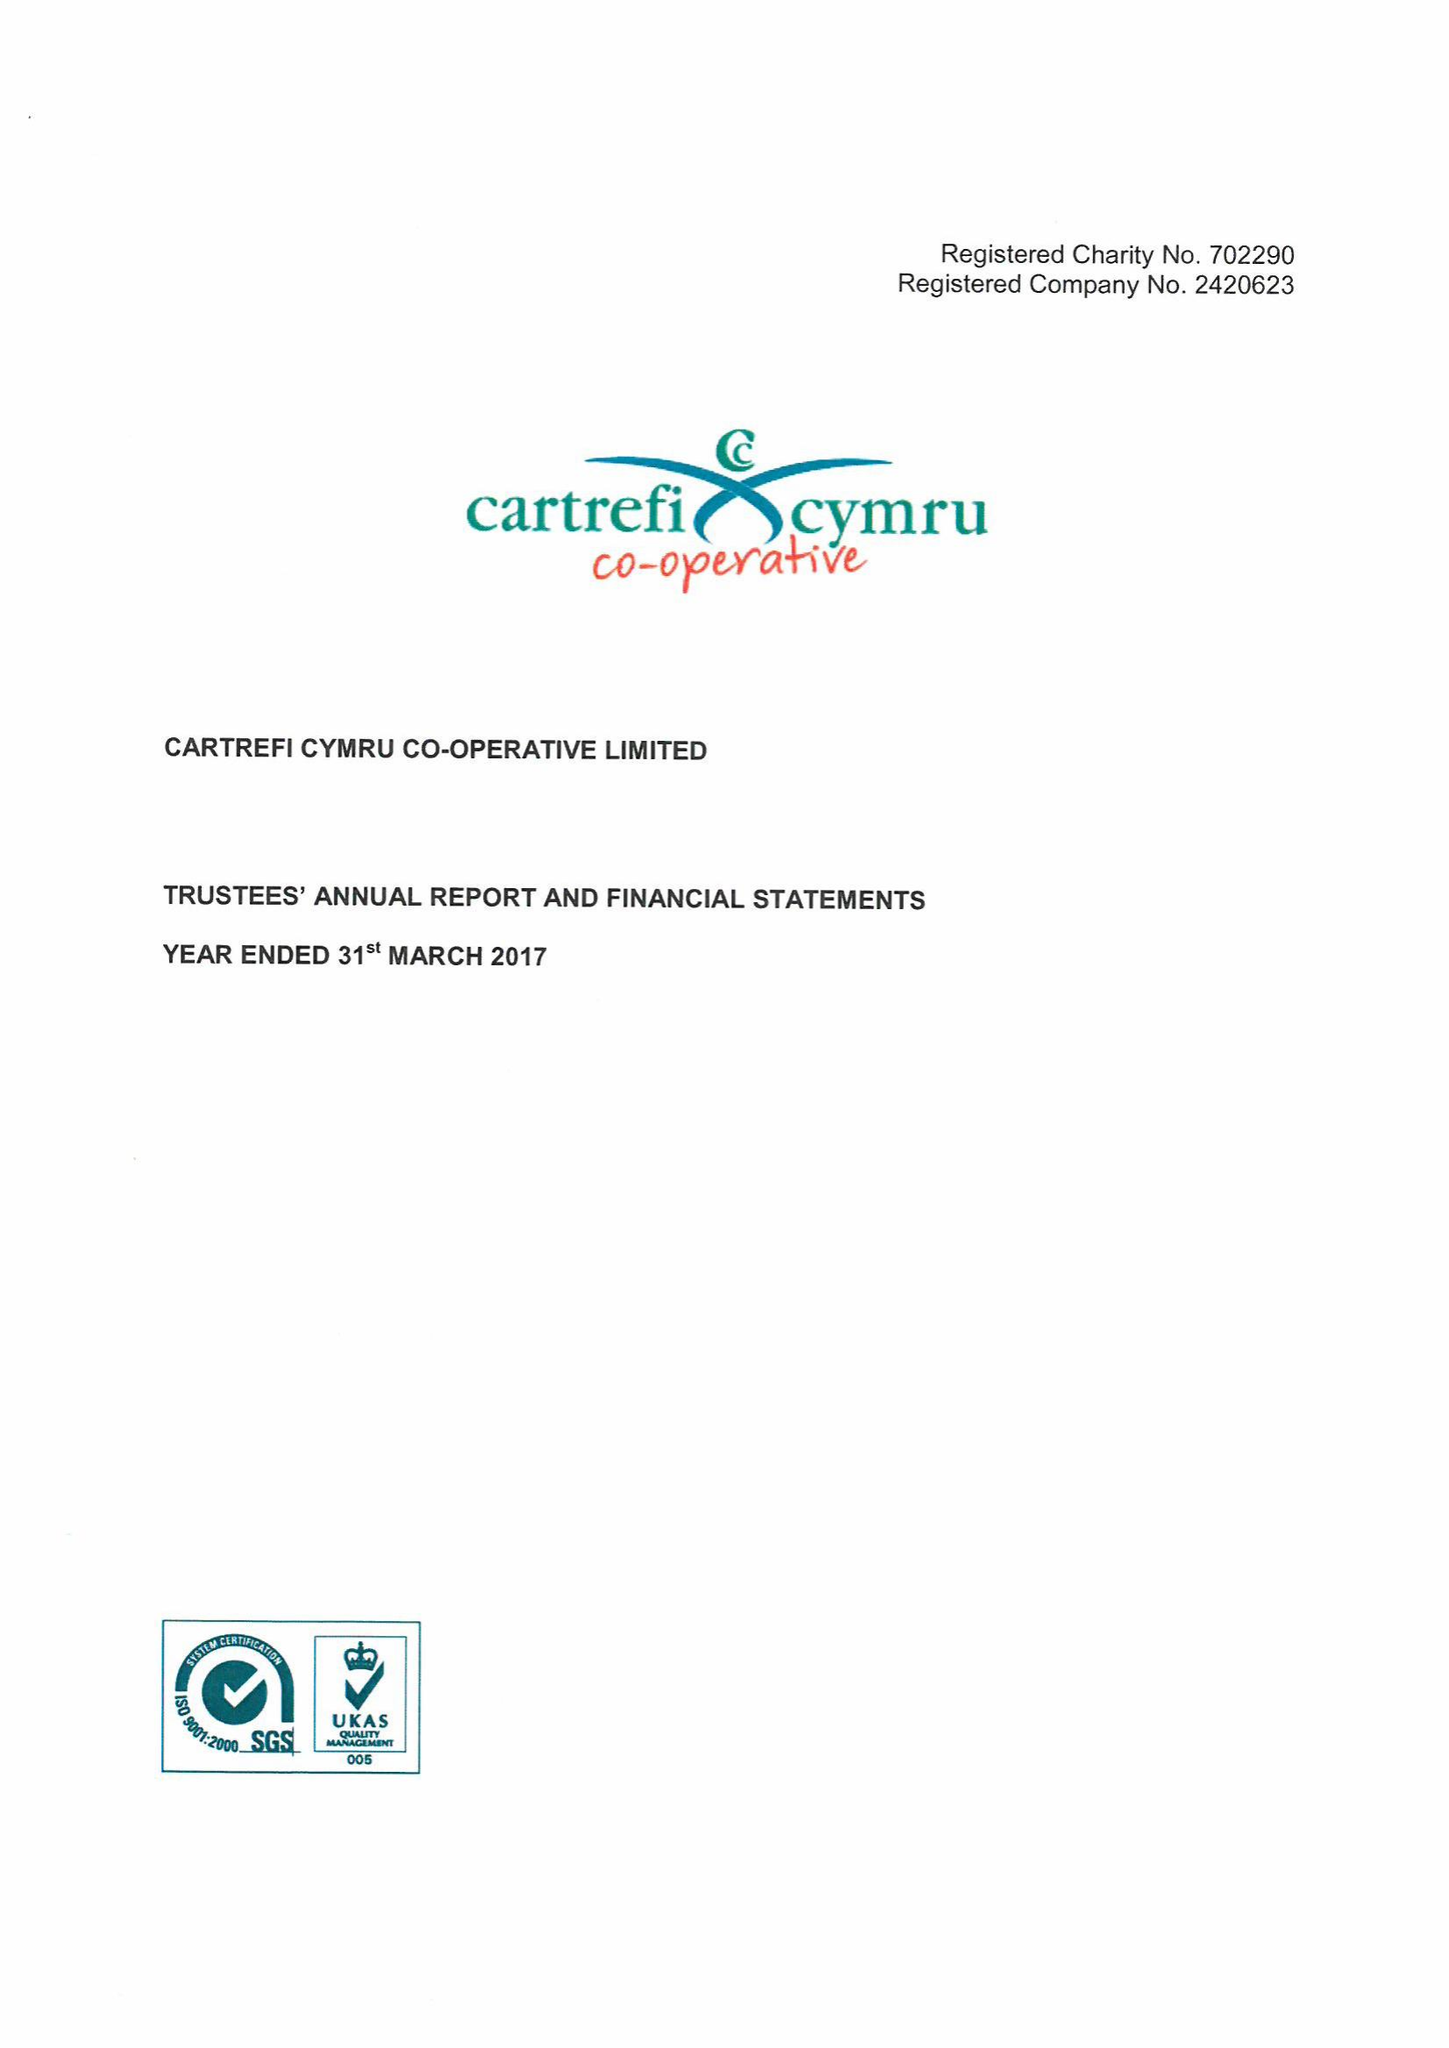What is the value for the address__post_town?
Answer the question using a single word or phrase. CARDIFF 